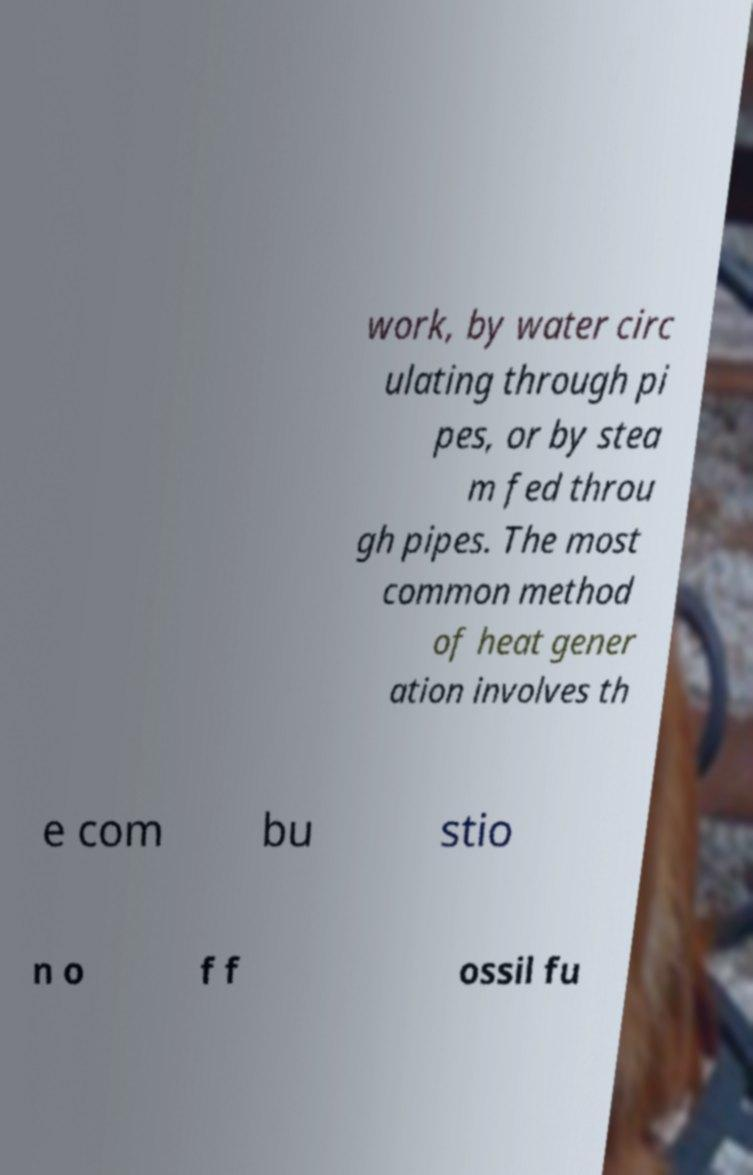For documentation purposes, I need the text within this image transcribed. Could you provide that? work, by water circ ulating through pi pes, or by stea m fed throu gh pipes. The most common method of heat gener ation involves th e com bu stio n o f f ossil fu 